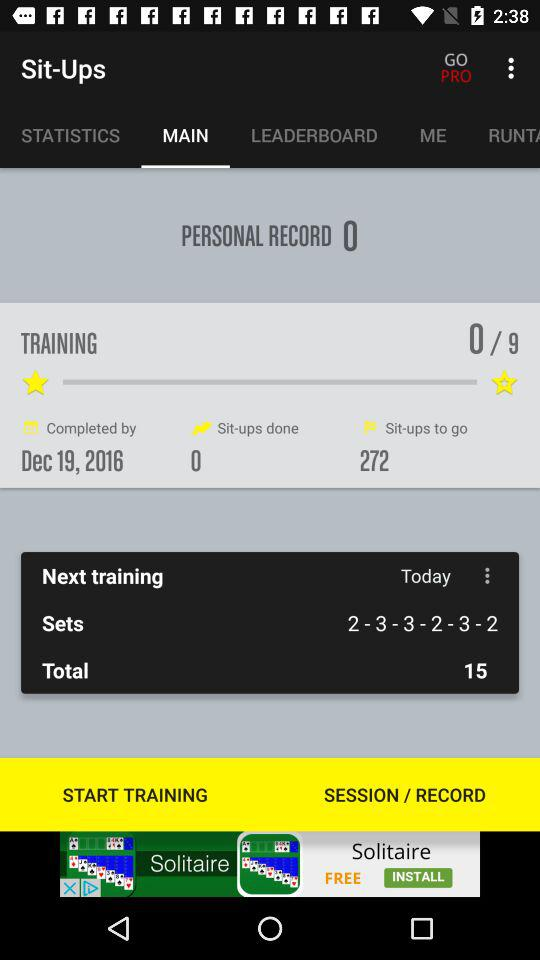How many sit-ups to go? The sit-up to go is 272. 